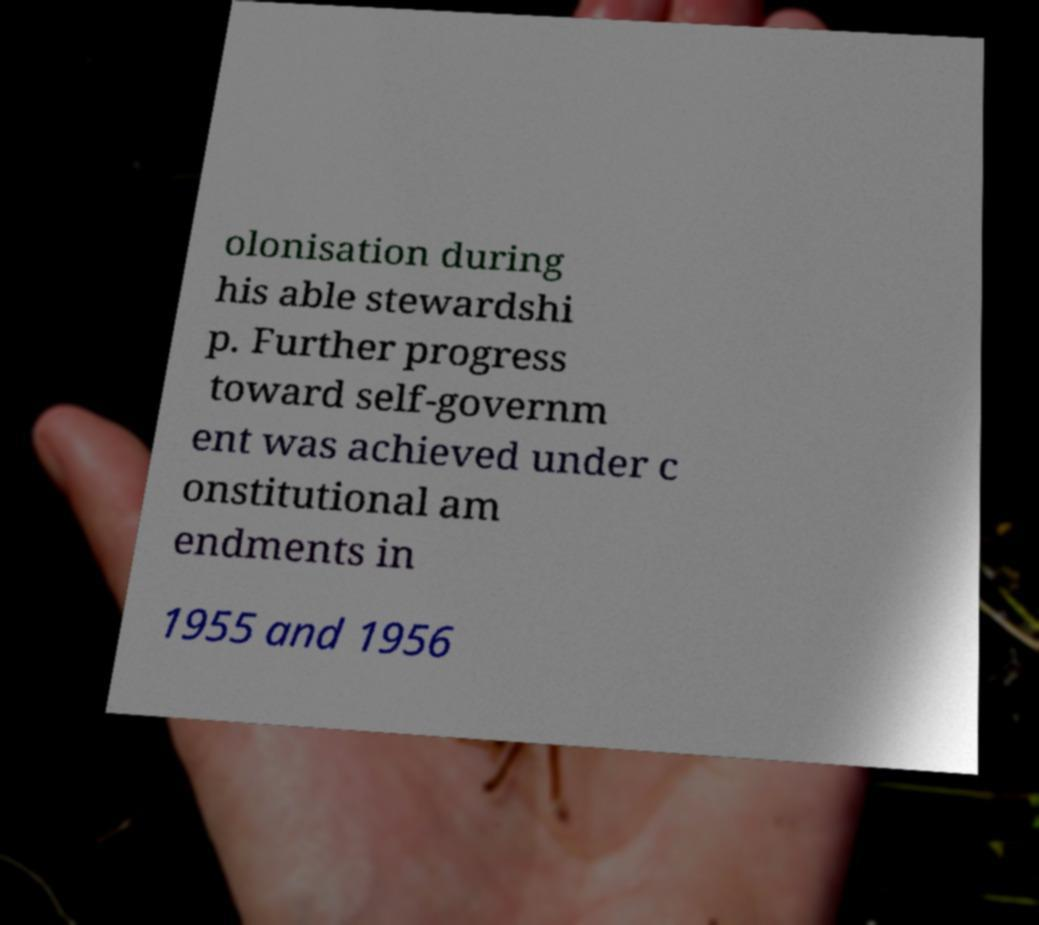There's text embedded in this image that I need extracted. Can you transcribe it verbatim? olonisation during his able stewardshi p. Further progress toward self-governm ent was achieved under c onstitutional am endments in 1955 and 1956 